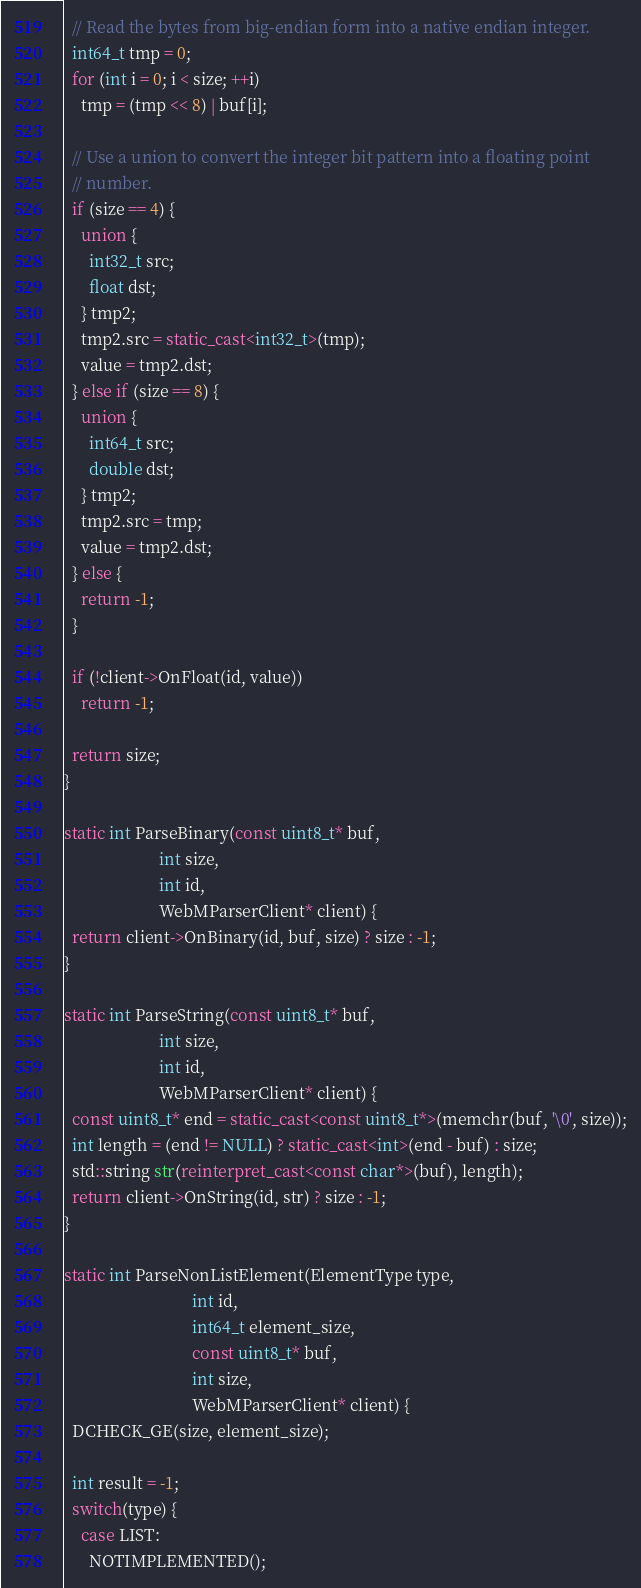<code> <loc_0><loc_0><loc_500><loc_500><_C++_>  // Read the bytes from big-endian form into a native endian integer.
  int64_t tmp = 0;
  for (int i = 0; i < size; ++i)
    tmp = (tmp << 8) | buf[i];

  // Use a union to convert the integer bit pattern into a floating point
  // number.
  if (size == 4) {
    union {
      int32_t src;
      float dst;
    } tmp2;
    tmp2.src = static_cast<int32_t>(tmp);
    value = tmp2.dst;
  } else if (size == 8) {
    union {
      int64_t src;
      double dst;
    } tmp2;
    tmp2.src = tmp;
    value = tmp2.dst;
  } else {
    return -1;
  }

  if (!client->OnFloat(id, value))
    return -1;

  return size;
}

static int ParseBinary(const uint8_t* buf,
                       int size,
                       int id,
                       WebMParserClient* client) {
  return client->OnBinary(id, buf, size) ? size : -1;
}

static int ParseString(const uint8_t* buf,
                       int size,
                       int id,
                       WebMParserClient* client) {
  const uint8_t* end = static_cast<const uint8_t*>(memchr(buf, '\0', size));
  int length = (end != NULL) ? static_cast<int>(end - buf) : size;
  std::string str(reinterpret_cast<const char*>(buf), length);
  return client->OnString(id, str) ? size : -1;
}

static int ParseNonListElement(ElementType type,
                               int id,
                               int64_t element_size,
                               const uint8_t* buf,
                               int size,
                               WebMParserClient* client) {
  DCHECK_GE(size, element_size);

  int result = -1;
  switch(type) {
    case LIST:
      NOTIMPLEMENTED();</code> 